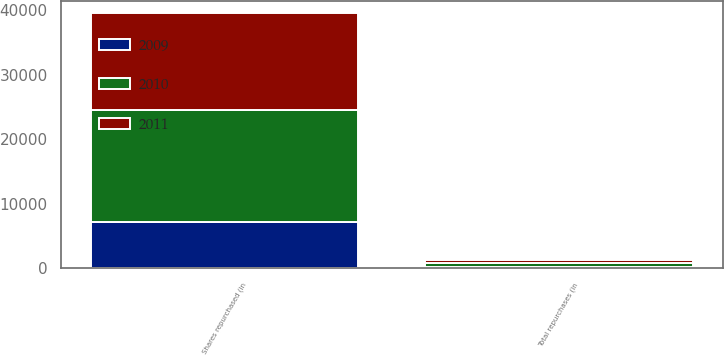Convert chart to OTSL. <chart><loc_0><loc_0><loc_500><loc_500><stacked_bar_chart><ecel><fcel>Shares repurchased (in<fcel>Total repurchases (in<nl><fcel>2010<fcel>17338<fcel>575<nl><fcel>2011<fcel>14920<fcel>501<nl><fcel>2009<fcel>7237<fcel>226<nl></chart> 